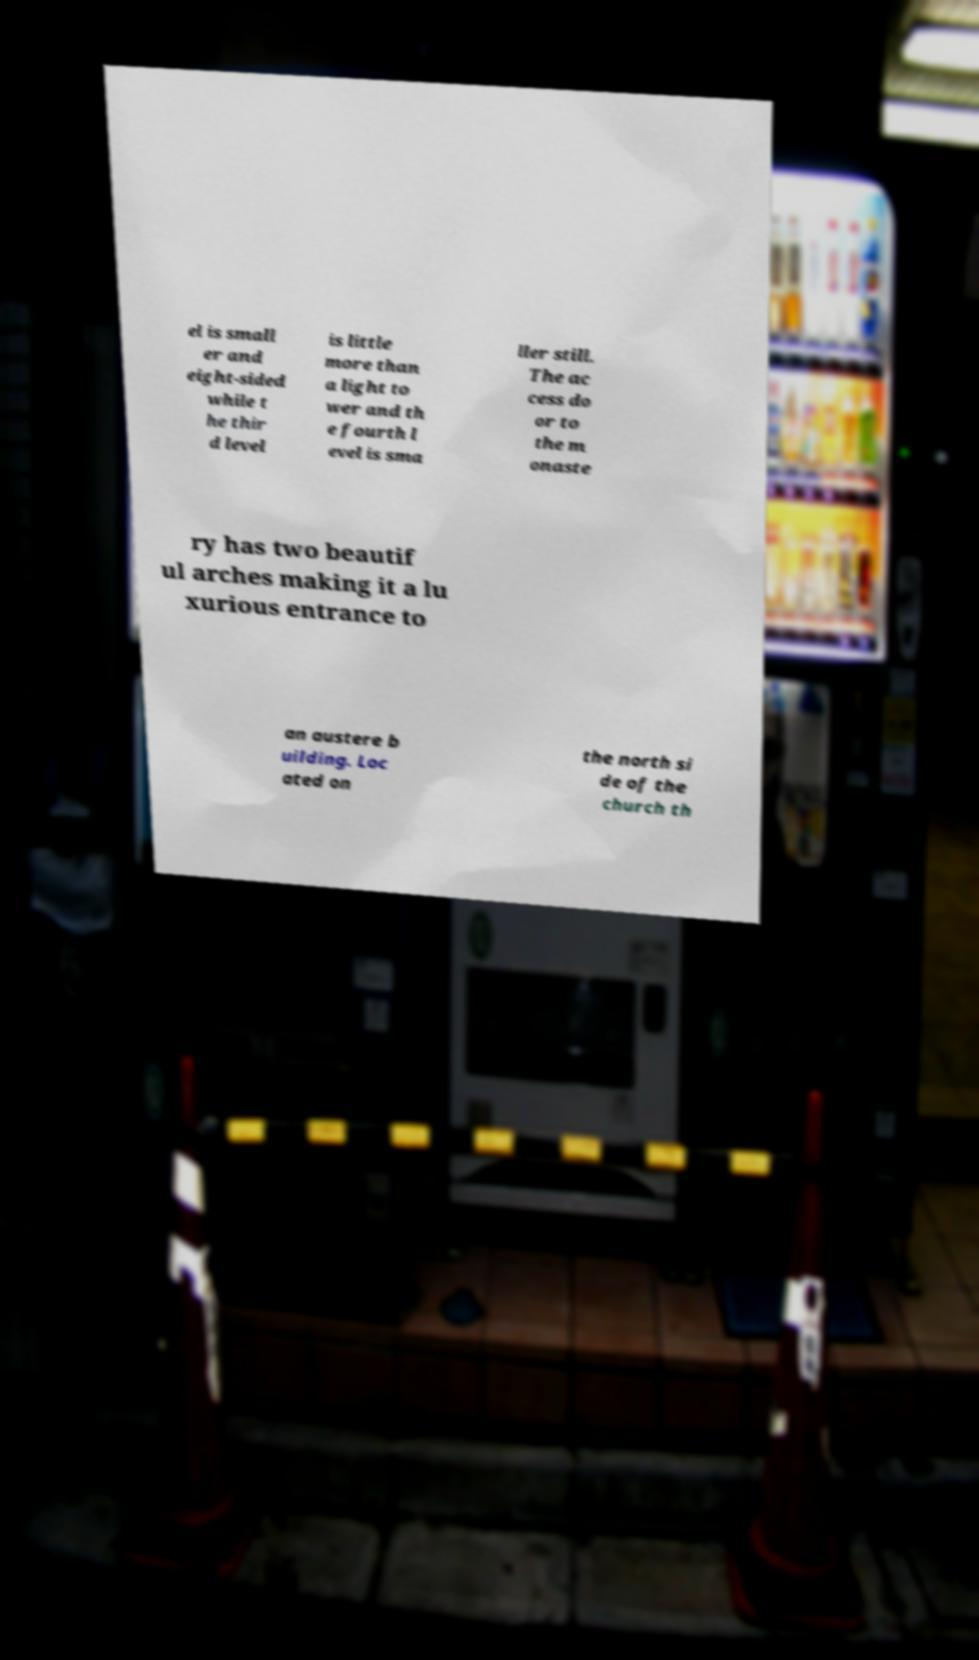Please read and relay the text visible in this image. What does it say? el is small er and eight-sided while t he thir d level is little more than a light to wer and th e fourth l evel is sma ller still. The ac cess do or to the m onaste ry has two beautif ul arches making it a lu xurious entrance to an austere b uilding. Loc ated on the north si de of the church th 